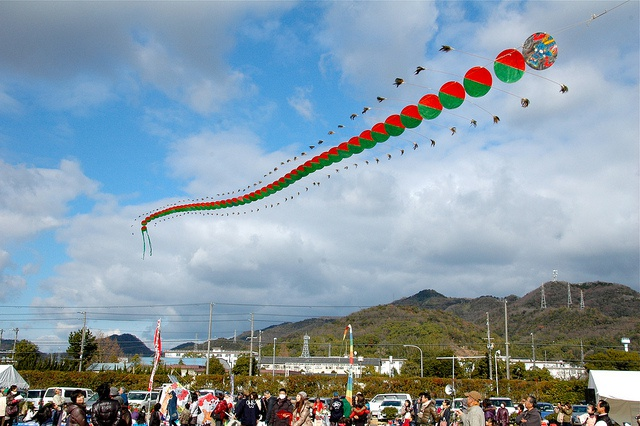Describe the objects in this image and their specific colors. I can see kite in darkgray, lightblue, lightgray, and red tones, people in darkgray, black, gray, maroon, and white tones, truck in darkgray, black, gray, and white tones, people in darkgray, black, and gray tones, and people in darkgray, lightgray, and tan tones in this image. 